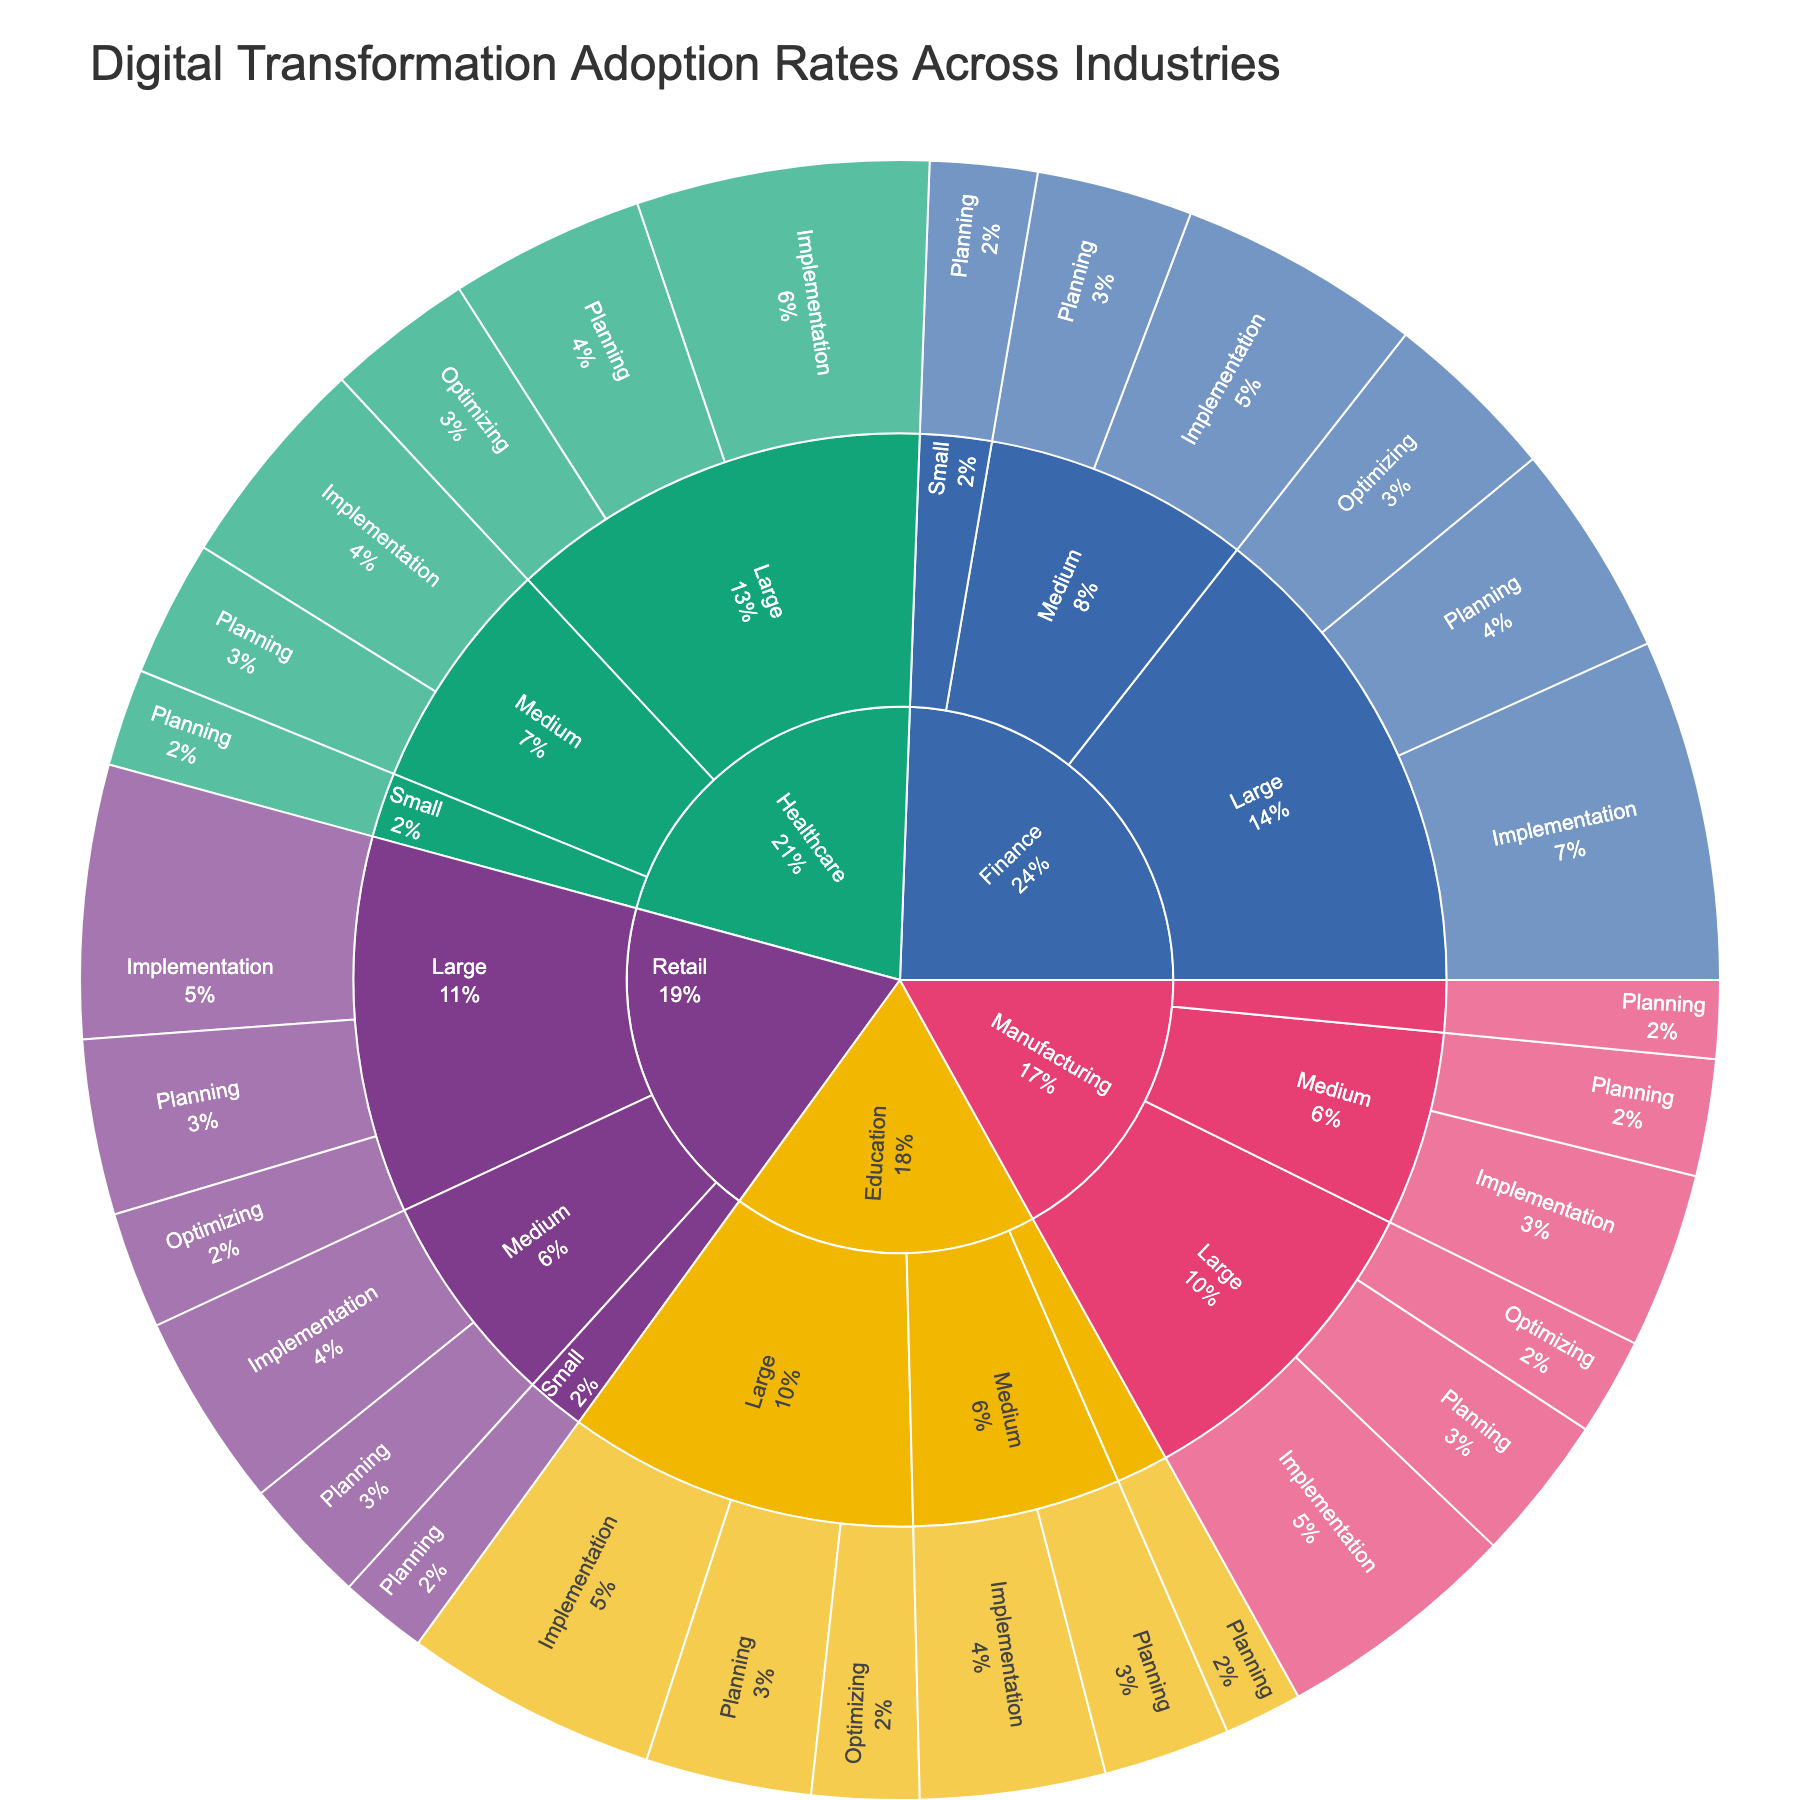What's the title of the figure? The title is usually displayed at the top of the figure. From the specification, the title is given as 'Digital Transformation Adoption Rates Across Industries'.
Answer: Digital Transformation Adoption Rates Across Industries Which industry has the highest value in the 'Planning' stage for large companies? Look at all the industries at the 'Planning' stage under 'Large' companies and compare their values. 'Finance' large companies have the highest value at 22.
Answer: Finance How many total cases are there in the 'Implementation' stage across all industries? Sum up the values in the 'Implementation' stage for all industries: Manufacturing (25 + 18), Healthcare (30 + 22), Retail (28 + 20), Finance (35 + 25), Education (26 + 19). (25 + 18 + 30 + 22 + 28 + 20 + 35 + 25 + 26 + 19 = 248).
Answer: 248 Which industry has the smallest value in the 'Planning' stage for small companies? Look at all the industries at the 'Planning' stage under 'Small' companies and compare their values. Manufacturing, Education, and Retail have the lowest value of 8.
Answer: Manufacturing, Education, Retail What percentage of the total value in Retail is from large companies? In Retail, sum the values for large companies (18+28+12=58). Sum the total values for Retail (18+28+12+13+20+9=100). Calculate the percentage (58/100 = 0.58 = 58%).
Answer: 58% What is the difference in the 'Implementation' stage values between Healthcare and Education for medium companies? Look at the 'Implementation' stage values for Healthcare (22) and Education (19) medium companies. Subtract the smaller from the larger (22 - 19 = 3).
Answer: 3 Which implementation stage has the highest total value across all industries and company sizes? Sum the values for each stage across all industries and company sizes: Planning (15+12+8+20+14+10+18+13+9+22+16+11+17+13+8 = 196), Implementation (25+18+30+22+28+20+35+25+26+19 = 248), Optimizing (10+15+12+18+11 = 66). Implementation has the highest total value (248).
Answer: Implementation What proportion of the total 'Optimizing' stage value is attributed to the Healthcare industry? Sum the 'Optimizing' stage values from all industries (10+15+12+18+11 = 66). Healthcare industry contributes 15. Calculate the proportion (15/66 × 100 ≈ 22.73%).
Answer: ~22.73% Between Manufacturing and Retail, which industry has a greater total value in large companies? Sum the values for large companies in Manufacturing (15+25+10 = 50) and Retail (18+28+12 = 58). Compare the sums. Retail has a greater total value (58).
Answer: Retail What's the average 'Planning' stage value across all medium companies? Sum the 'Planning' stage values across medium companies (12+14+13+16+13 = 68). Count the number of medium companies (5). Calculate the average (68/5 = 13.6).
Answer: 13.6 